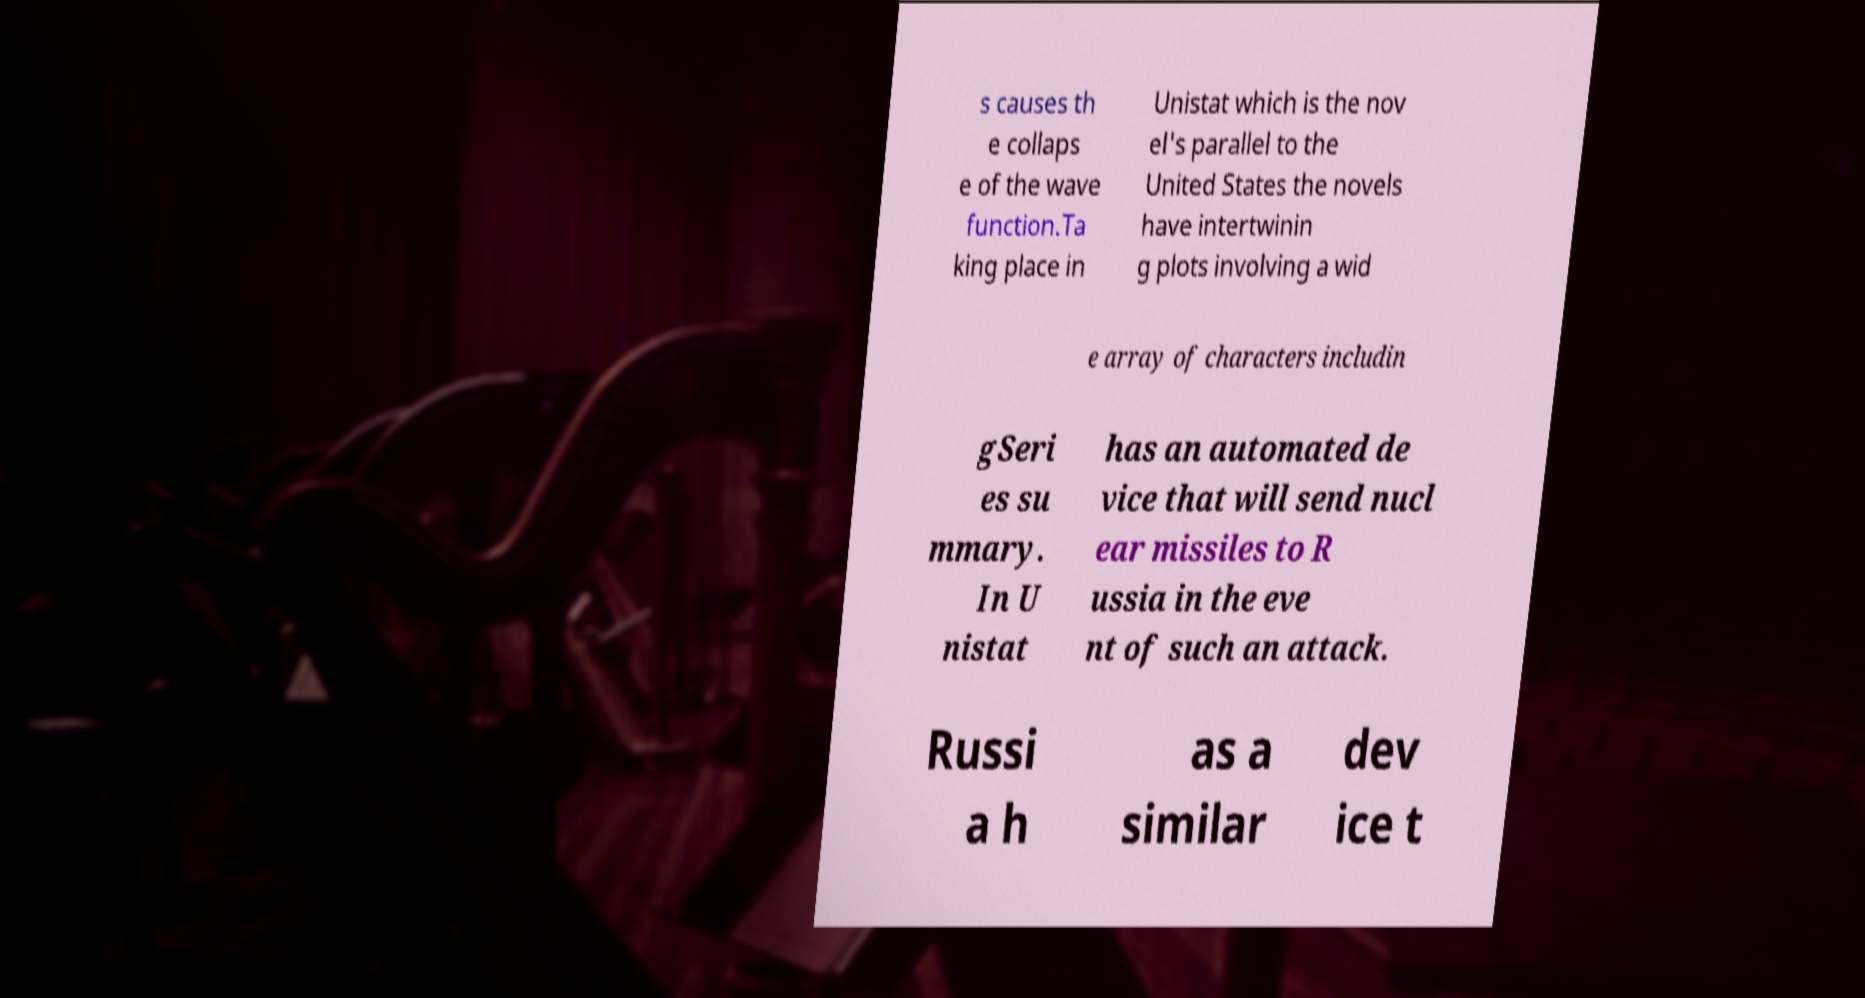Please identify and transcribe the text found in this image. s causes th e collaps e of the wave function.Ta king place in Unistat which is the nov el's parallel to the United States the novels have intertwinin g plots involving a wid e array of characters includin gSeri es su mmary. In U nistat has an automated de vice that will send nucl ear missiles to R ussia in the eve nt of such an attack. Russi a h as a similar dev ice t 